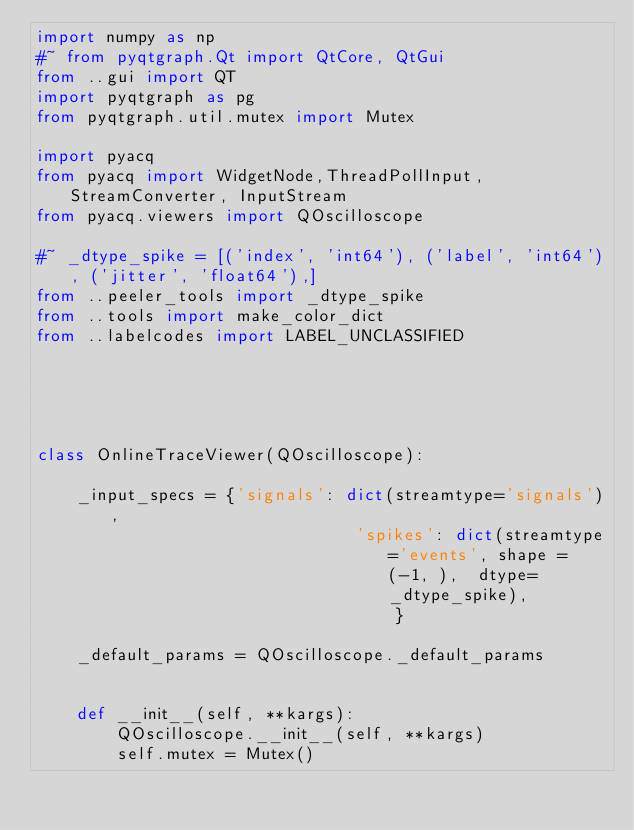Convert code to text. <code><loc_0><loc_0><loc_500><loc_500><_Python_>import numpy as np
#~ from pyqtgraph.Qt import QtCore, QtGui
from ..gui import QT
import pyqtgraph as pg
from pyqtgraph.util.mutex import Mutex

import pyacq
from pyacq import WidgetNode,ThreadPollInput, StreamConverter, InputStream
from pyacq.viewers import QOscilloscope

#~ _dtype_spike = [('index', 'int64'), ('label', 'int64'), ('jitter', 'float64'),]
from ..peeler_tools import _dtype_spike
from ..tools import make_color_dict
from ..labelcodes import LABEL_UNCLASSIFIED




    
class OnlineTraceViewer(QOscilloscope):
    
    _input_specs = {'signals': dict(streamtype='signals'),
                                'spikes': dict(streamtype='events', shape = (-1, ),  dtype=_dtype_spike),
                                    }
    
    _default_params = QOscilloscope._default_params

    
    def __init__(self, **kargs):
        QOscilloscope.__init__(self, **kargs)
        self.mutex = Mutex()
</code> 